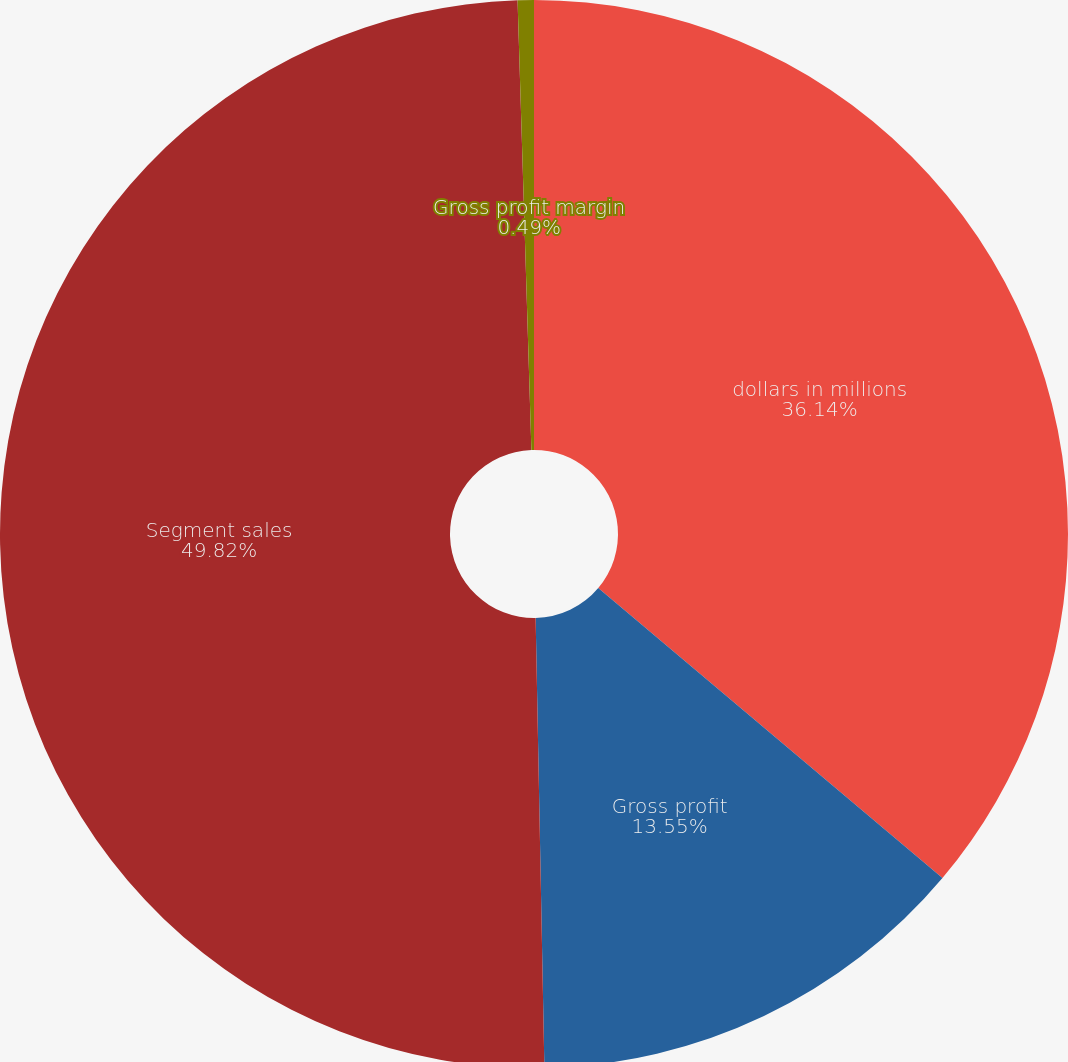Convert chart to OTSL. <chart><loc_0><loc_0><loc_500><loc_500><pie_chart><fcel>dollars in millions<fcel>Gross profit<fcel>Segment sales<fcel>Gross profit margin<nl><fcel>36.14%<fcel>13.55%<fcel>49.82%<fcel>0.49%<nl></chart> 